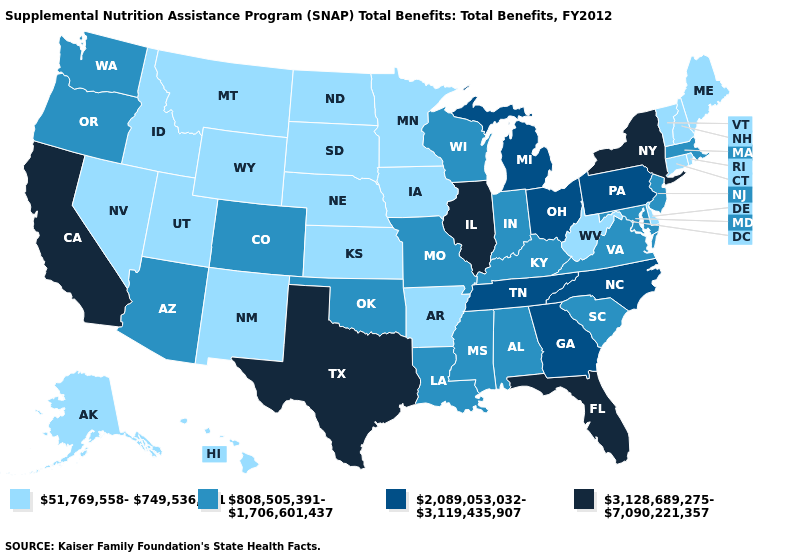What is the value of Louisiana?
Concise answer only. 808,505,391-1,706,601,437. What is the highest value in the USA?
Give a very brief answer. 3,128,689,275-7,090,221,357. Does New York have the highest value in the USA?
Be succinct. Yes. Does Texas have the highest value in the South?
Answer briefly. Yes. What is the highest value in the South ?
Be succinct. 3,128,689,275-7,090,221,357. Among the states that border Alabama , does Florida have the highest value?
Write a very short answer. Yes. What is the value of Wisconsin?
Short answer required. 808,505,391-1,706,601,437. Which states have the highest value in the USA?
Be succinct. California, Florida, Illinois, New York, Texas. What is the lowest value in states that border Delaware?
Short answer required. 808,505,391-1,706,601,437. What is the value of Illinois?
Be succinct. 3,128,689,275-7,090,221,357. Name the states that have a value in the range 2,089,053,032-3,119,435,907?
Keep it brief. Georgia, Michigan, North Carolina, Ohio, Pennsylvania, Tennessee. What is the lowest value in the USA?
Be succinct. 51,769,558-749,536,081. Name the states that have a value in the range 3,128,689,275-7,090,221,357?
Short answer required. California, Florida, Illinois, New York, Texas. Does Kansas have the same value as New Jersey?
Keep it brief. No. Name the states that have a value in the range 808,505,391-1,706,601,437?
Keep it brief. Alabama, Arizona, Colorado, Indiana, Kentucky, Louisiana, Maryland, Massachusetts, Mississippi, Missouri, New Jersey, Oklahoma, Oregon, South Carolina, Virginia, Washington, Wisconsin. 